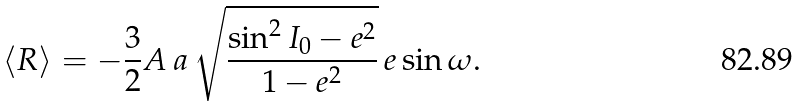<formula> <loc_0><loc_0><loc_500><loc_500>\left < R \right > = - \frac { 3 } { 2 } A \, a \, \sqrt { \frac { \sin ^ { 2 } I _ { 0 } - e ^ { 2 } } { 1 - e ^ { 2 } } } \, e \sin \omega .</formula> 